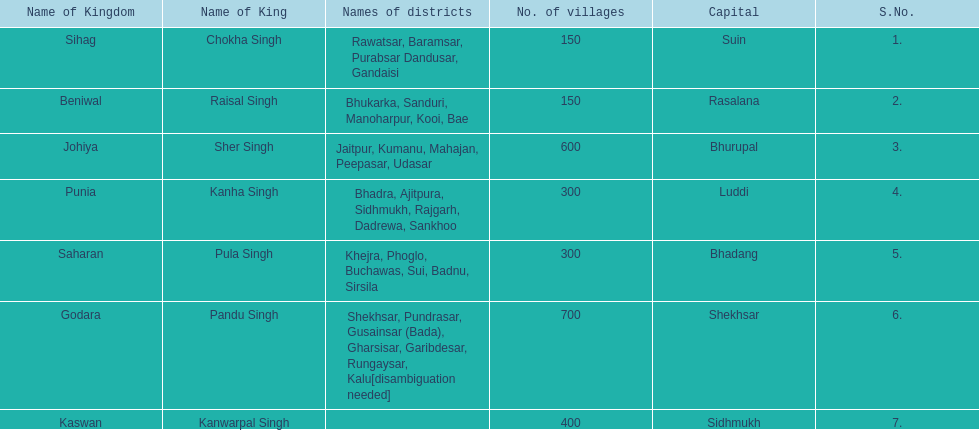Which kingdom contained the second most villages, next only to godara? Johiya. 